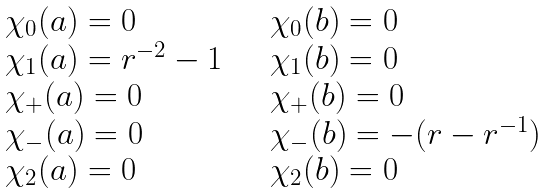Convert formula to latex. <formula><loc_0><loc_0><loc_500><loc_500>\begin{array} { l l } \chi _ { 0 } ( a ) = 0 & \quad \chi _ { 0 } ( b ) = 0 \\ \chi _ { 1 } ( a ) = r ^ { - 2 } - 1 & \quad \chi _ { 1 } ( b ) = 0 \\ \chi _ { + } ( a ) = 0 & \quad \chi _ { + } ( b ) = 0 \\ \chi _ { - } ( a ) = 0 & \quad \chi _ { - } ( b ) = - ( r - r ^ { - 1 } ) \\ \chi _ { 2 } ( a ) = 0 & \quad \chi _ { 2 } ( b ) = 0 \\ \end{array}</formula> 